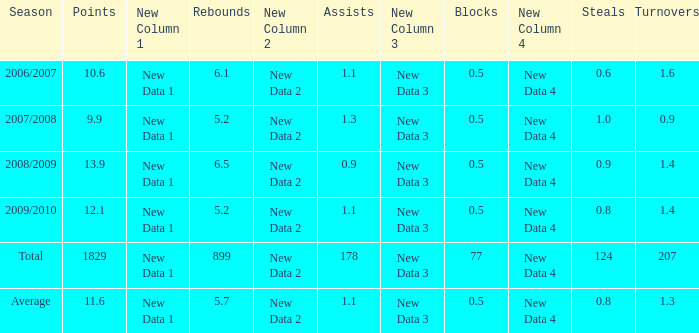What is the maximum rebounds when there are 0.9 steals and fewer than 1.4 turnovers? None. 